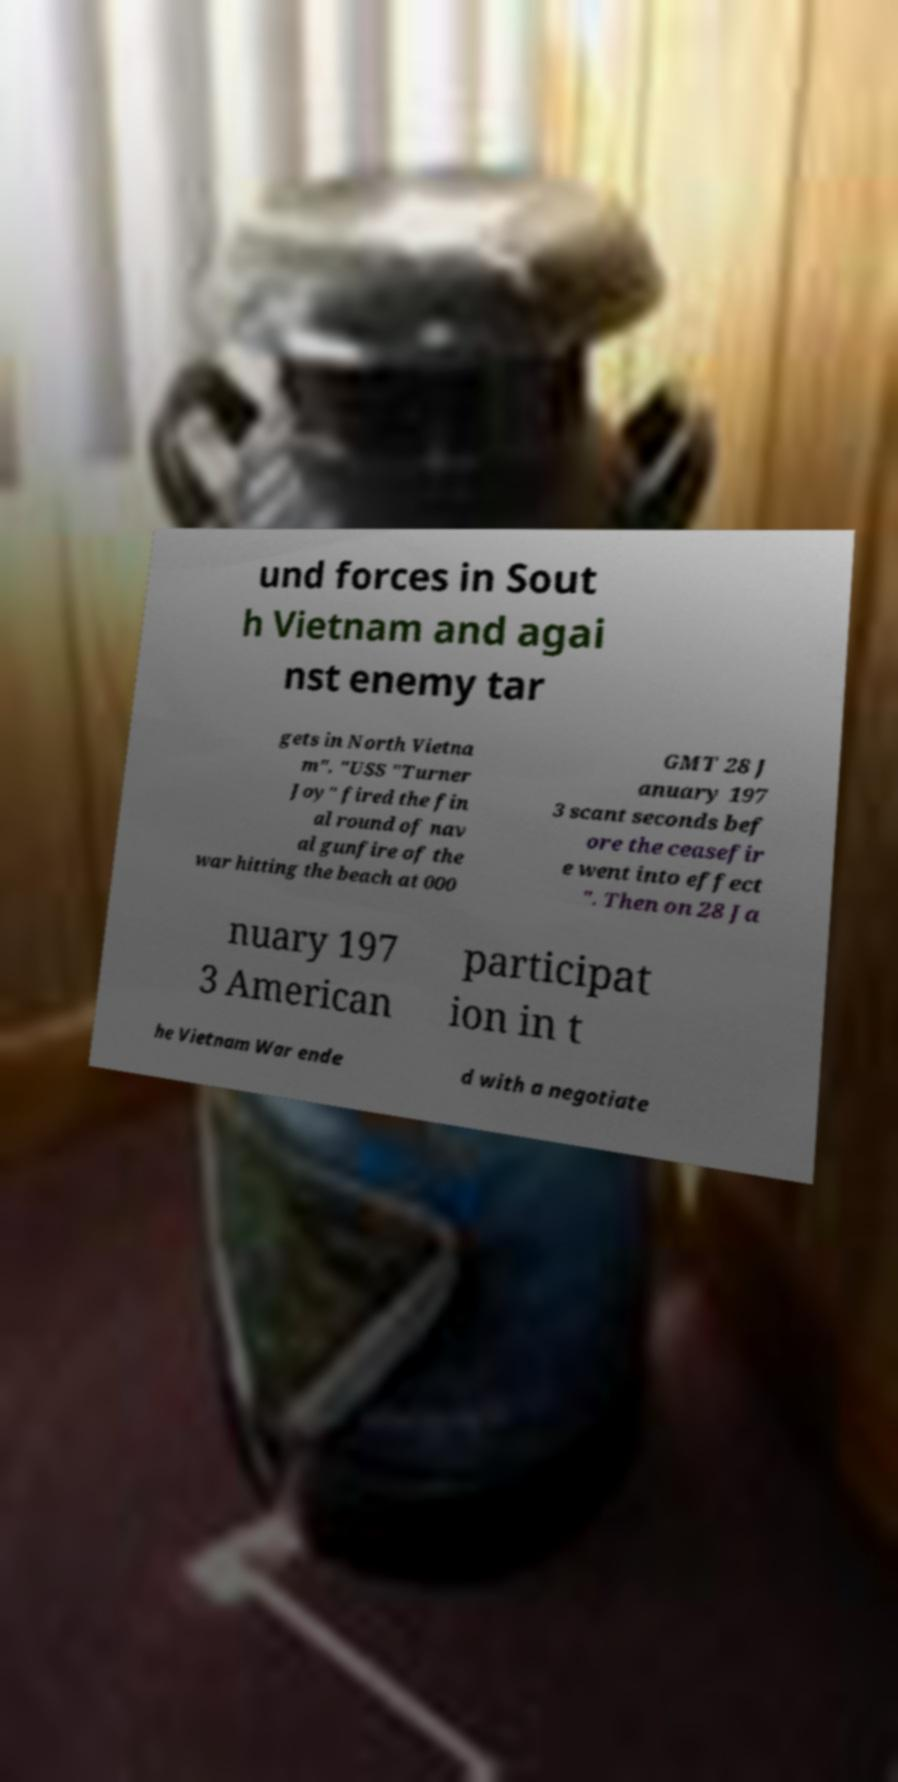Could you assist in decoding the text presented in this image and type it out clearly? und forces in Sout h Vietnam and agai nst enemy tar gets in North Vietna m". "USS "Turner Joy" fired the fin al round of nav al gunfire of the war hitting the beach at 000 GMT 28 J anuary 197 3 scant seconds bef ore the ceasefir e went into effect ". Then on 28 Ja nuary 197 3 American participat ion in t he Vietnam War ende d with a negotiate 